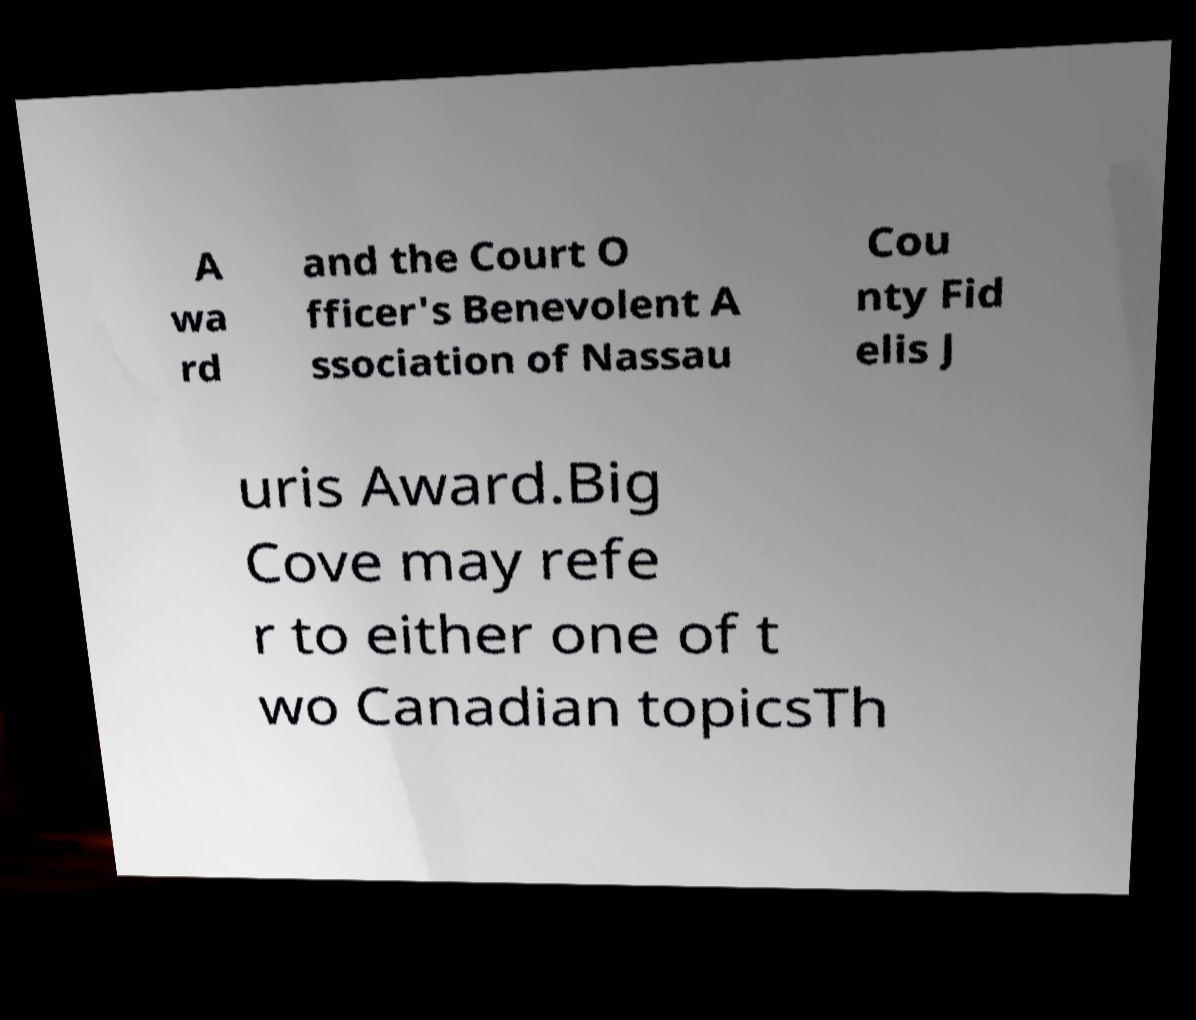What messages or text are displayed in this image? I need them in a readable, typed format. A wa rd and the Court O fficer's Benevolent A ssociation of Nassau Cou nty Fid elis J uris Award.Big Cove may refe r to either one of t wo Canadian topicsTh 